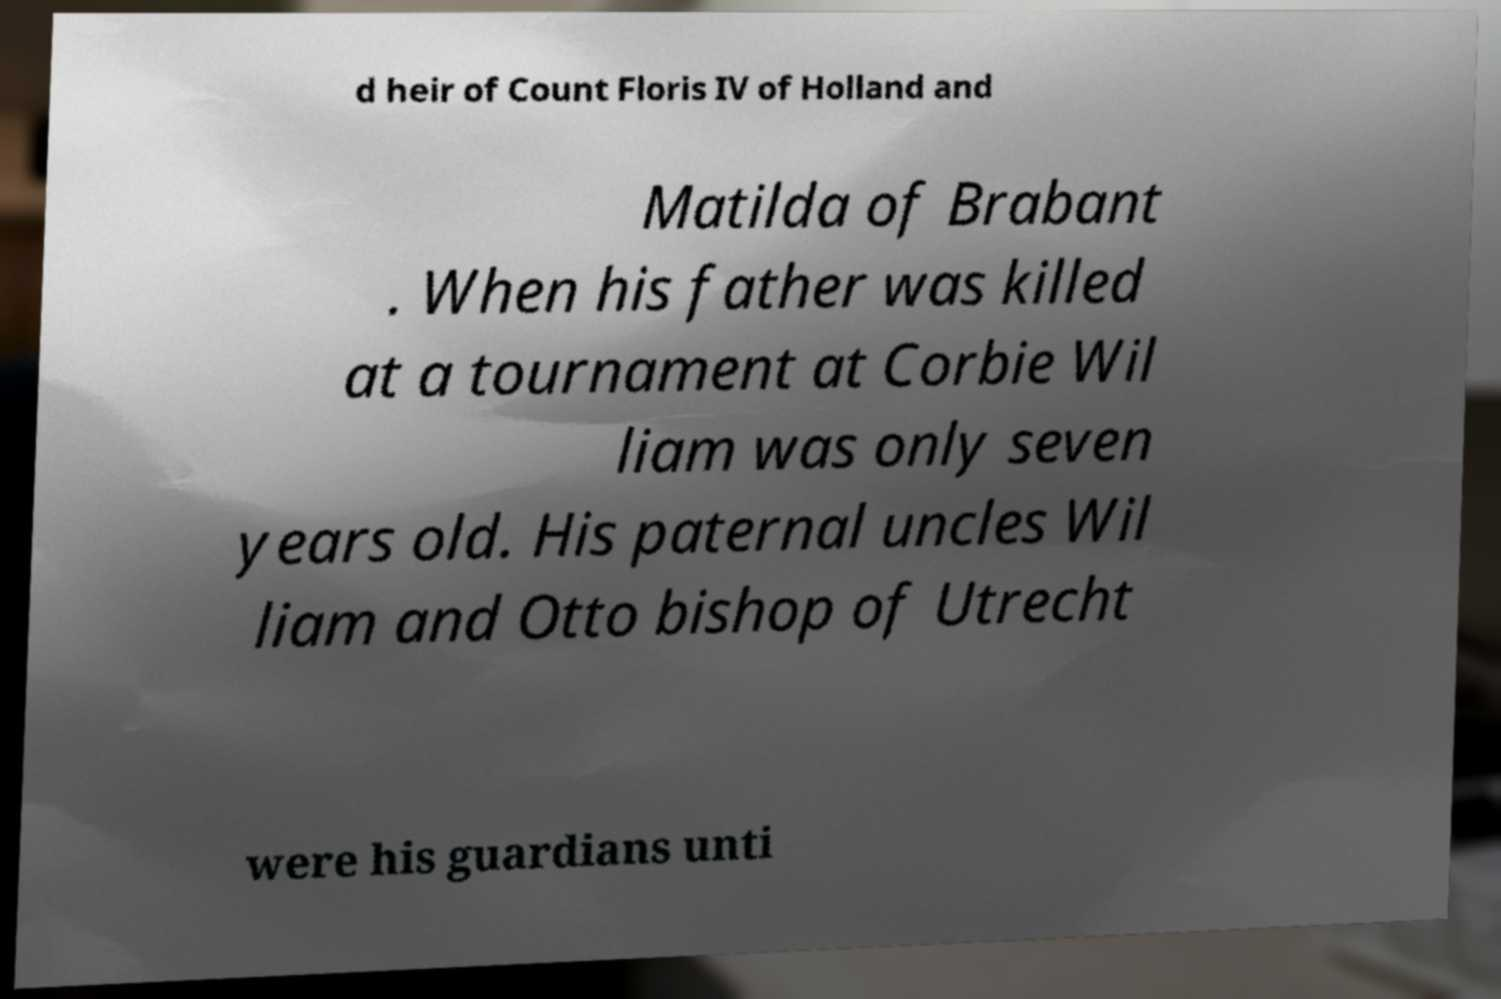Please identify and transcribe the text found in this image. d heir of Count Floris IV of Holland and Matilda of Brabant . When his father was killed at a tournament at Corbie Wil liam was only seven years old. His paternal uncles Wil liam and Otto bishop of Utrecht were his guardians unti 